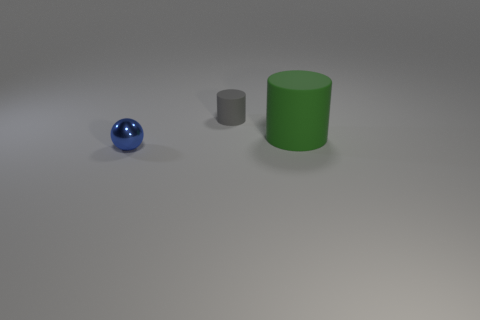Are there more brown shiny cylinders than small gray matte cylinders?
Your response must be concise. No. Do the tiny object behind the blue ball and the large green cylinder have the same material?
Provide a short and direct response. Yes. Are there fewer large metal blocks than gray things?
Provide a short and direct response. Yes. There is a matte cylinder in front of the small object that is behind the tiny blue metal ball; are there any small blue shiny objects that are to the right of it?
Offer a terse response. No. There is a small object that is right of the small shiny thing; is its shape the same as the green object?
Give a very brief answer. Yes. Are there more objects behind the tiny gray thing than purple matte things?
Your answer should be very brief. No. Does the cylinder that is in front of the tiny cylinder have the same color as the tiny metallic ball?
Offer a very short reply. No. Are there any other things that have the same color as the small sphere?
Offer a very short reply. No. The rubber cylinder right of the cylinder behind the big cylinder right of the small rubber thing is what color?
Make the answer very short. Green. Does the metal thing have the same size as the gray rubber thing?
Offer a terse response. Yes. 